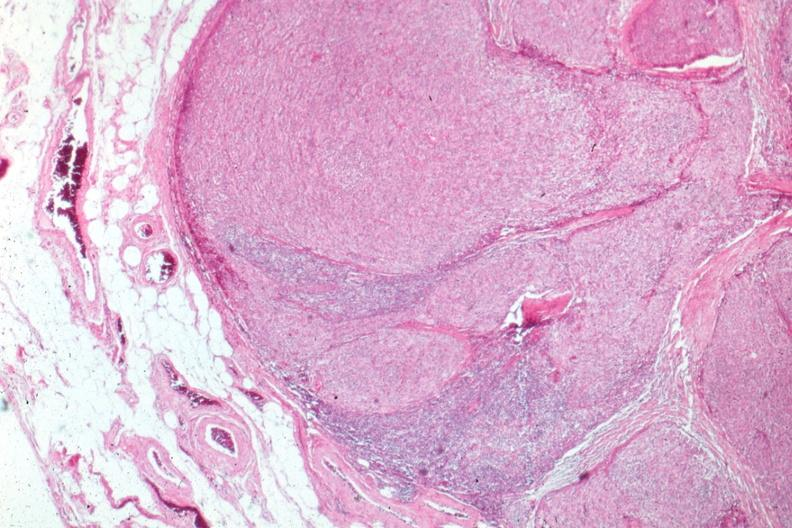s coronary atherosclerosis present?
Answer the question using a single word or phrase. No 